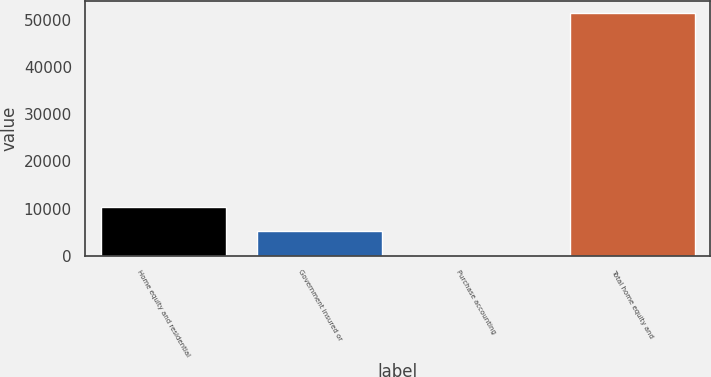Convert chart. <chart><loc_0><loc_0><loc_500><loc_500><bar_chart><fcel>Home equity and residential<fcel>Government insured or<fcel>Purchase accounting<fcel>Total home equity and<nl><fcel>10395.2<fcel>5255.6<fcel>116<fcel>51512<nl></chart> 